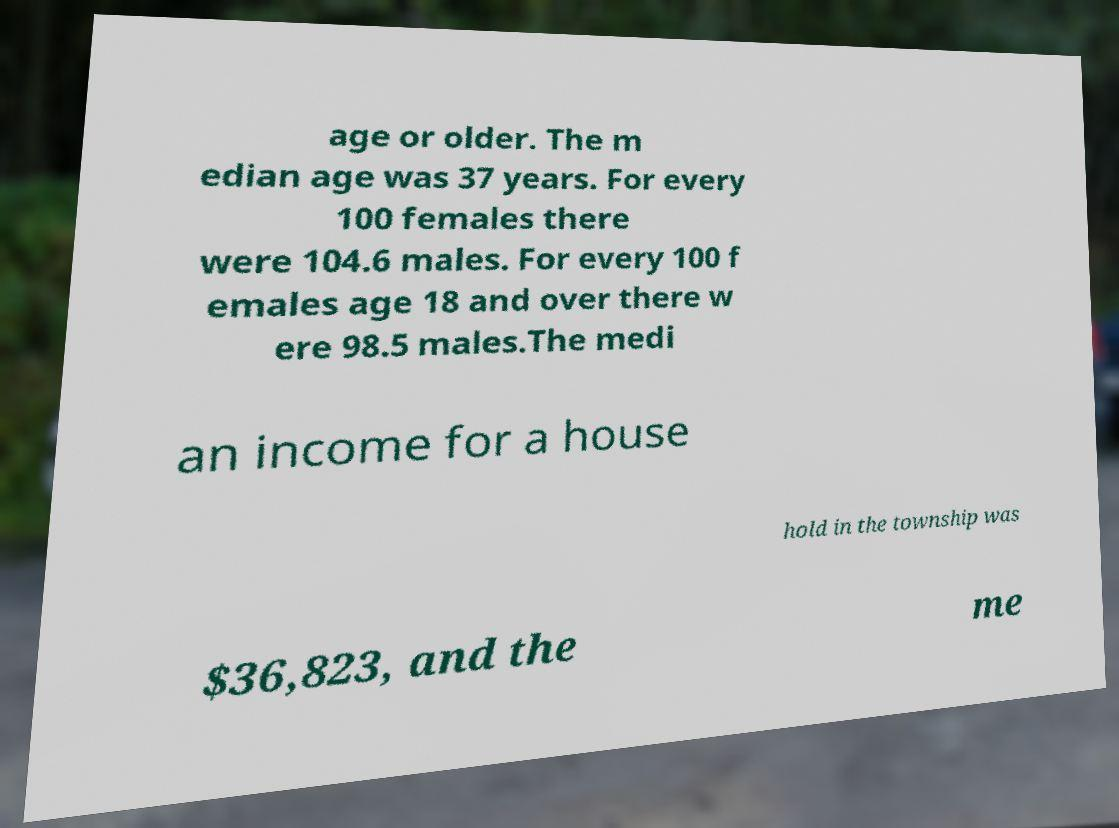Please read and relay the text visible in this image. What does it say? age or older. The m edian age was 37 years. For every 100 females there were 104.6 males. For every 100 f emales age 18 and over there w ere 98.5 males.The medi an income for a house hold in the township was $36,823, and the me 